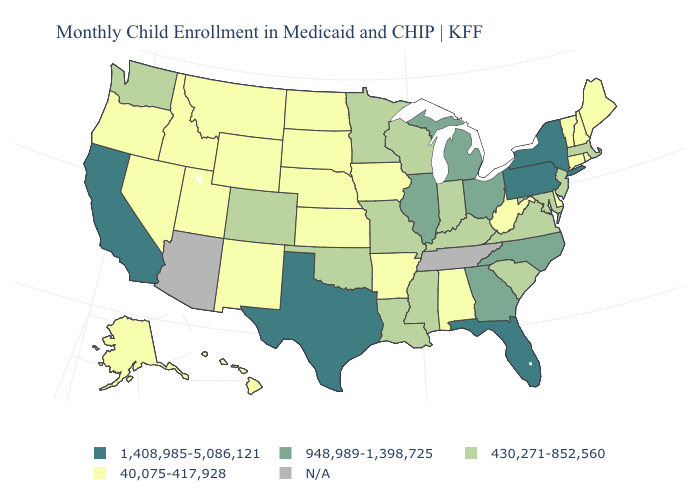Name the states that have a value in the range N/A?
Keep it brief. Arizona, Tennessee. What is the value of Mississippi?
Concise answer only. 430,271-852,560. Name the states that have a value in the range 430,271-852,560?
Keep it brief. Colorado, Indiana, Kentucky, Louisiana, Maryland, Massachusetts, Minnesota, Mississippi, Missouri, New Jersey, Oklahoma, South Carolina, Virginia, Washington, Wisconsin. Which states have the lowest value in the South?
Be succinct. Alabama, Arkansas, Delaware, West Virginia. What is the lowest value in states that border South Dakota?
Quick response, please. 40,075-417,928. Name the states that have a value in the range 40,075-417,928?
Short answer required. Alabama, Alaska, Arkansas, Connecticut, Delaware, Hawaii, Idaho, Iowa, Kansas, Maine, Montana, Nebraska, Nevada, New Hampshire, New Mexico, North Dakota, Oregon, Rhode Island, South Dakota, Utah, Vermont, West Virginia, Wyoming. Name the states that have a value in the range 40,075-417,928?
Give a very brief answer. Alabama, Alaska, Arkansas, Connecticut, Delaware, Hawaii, Idaho, Iowa, Kansas, Maine, Montana, Nebraska, Nevada, New Hampshire, New Mexico, North Dakota, Oregon, Rhode Island, South Dakota, Utah, Vermont, West Virginia, Wyoming. Does Michigan have the highest value in the MidWest?
Keep it brief. Yes. What is the highest value in the MidWest ?
Be succinct. 948,989-1,398,725. Does the first symbol in the legend represent the smallest category?
Short answer required. No. Name the states that have a value in the range 1,408,985-5,086,121?
Short answer required. California, Florida, New York, Pennsylvania, Texas. Name the states that have a value in the range N/A?
Give a very brief answer. Arizona, Tennessee. What is the lowest value in the West?
Keep it brief. 40,075-417,928. 